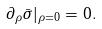Convert formula to latex. <formula><loc_0><loc_0><loc_500><loc_500>\partial _ { \rho } \bar { \sigma } | _ { \rho = 0 } = 0 .</formula> 